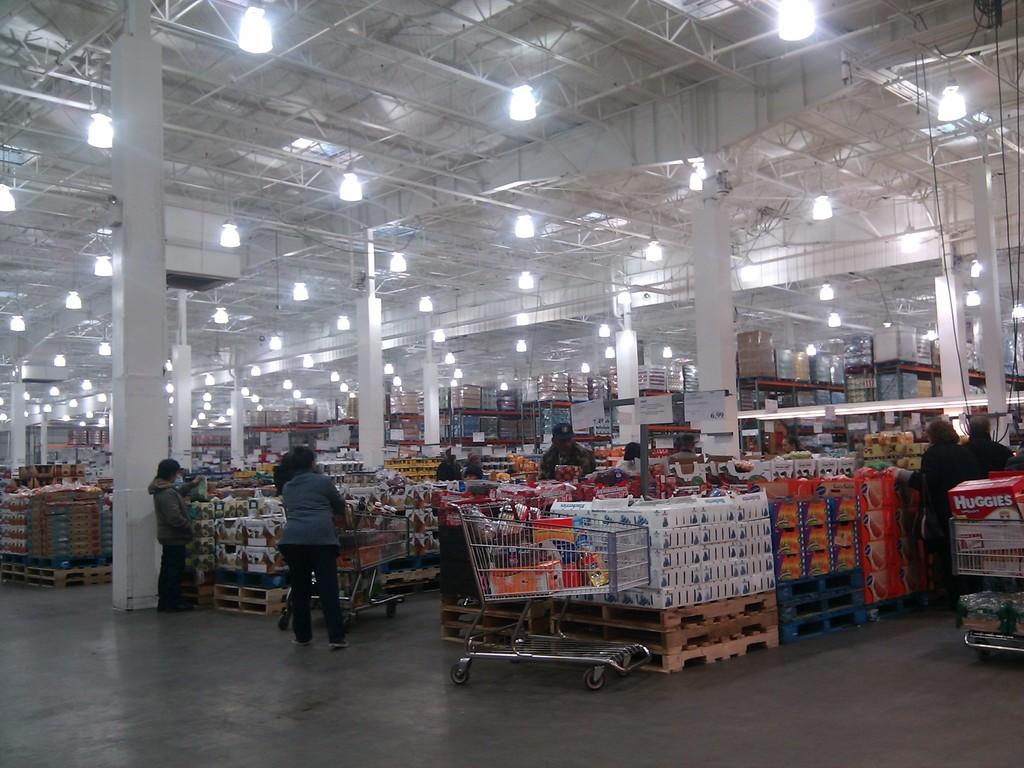<image>
Create a compact narrative representing the image presented. warehouse store has two big signs with a price of 6.99 on one and the other with 7.49. 